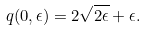Convert formula to latex. <formula><loc_0><loc_0><loc_500><loc_500>q ( 0 , \epsilon ) = 2 \sqrt { 2 \epsilon } + \epsilon .</formula> 